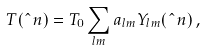<formula> <loc_0><loc_0><loc_500><loc_500>T ( \hat { \ } n ) = T _ { 0 } \sum _ { l m } a _ { l m } Y _ { l m } ( \hat { \ } n ) \, ,</formula> 